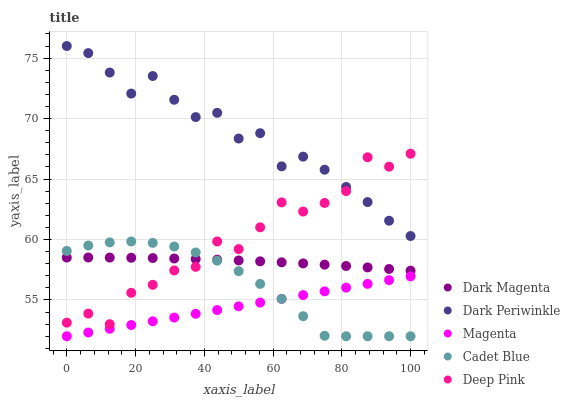Does Magenta have the minimum area under the curve?
Answer yes or no. Yes. Does Dark Periwinkle have the maximum area under the curve?
Answer yes or no. Yes. Does Cadet Blue have the minimum area under the curve?
Answer yes or no. No. Does Cadet Blue have the maximum area under the curve?
Answer yes or no. No. Is Magenta the smoothest?
Answer yes or no. Yes. Is Deep Pink the roughest?
Answer yes or no. Yes. Is Cadet Blue the smoothest?
Answer yes or no. No. Is Cadet Blue the roughest?
Answer yes or no. No. Does Magenta have the lowest value?
Answer yes or no. Yes. Does Dark Magenta have the lowest value?
Answer yes or no. No. Does Dark Periwinkle have the highest value?
Answer yes or no. Yes. Does Cadet Blue have the highest value?
Answer yes or no. No. Is Magenta less than Dark Magenta?
Answer yes or no. Yes. Is Dark Magenta greater than Magenta?
Answer yes or no. Yes. Does Cadet Blue intersect Dark Magenta?
Answer yes or no. Yes. Is Cadet Blue less than Dark Magenta?
Answer yes or no. No. Is Cadet Blue greater than Dark Magenta?
Answer yes or no. No. Does Magenta intersect Dark Magenta?
Answer yes or no. No. 